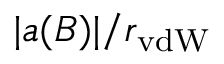<formula> <loc_0><loc_0><loc_500><loc_500>| a ( B ) | / r _ { v d W }</formula> 